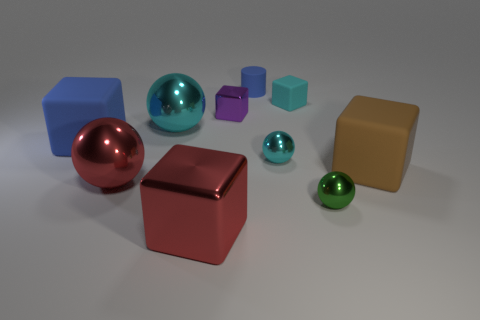Subtract 1 spheres. How many spheres are left? 3 Subtract all tiny cyan cubes. How many cubes are left? 4 Subtract all brown cubes. How many cubes are left? 4 Subtract all green blocks. Subtract all yellow balls. How many blocks are left? 5 Subtract all spheres. How many objects are left? 6 Add 3 big cyan spheres. How many big cyan spheres are left? 4 Add 4 cyan things. How many cyan things exist? 7 Subtract 1 brown cubes. How many objects are left? 9 Subtract all tiny blocks. Subtract all large red cubes. How many objects are left? 7 